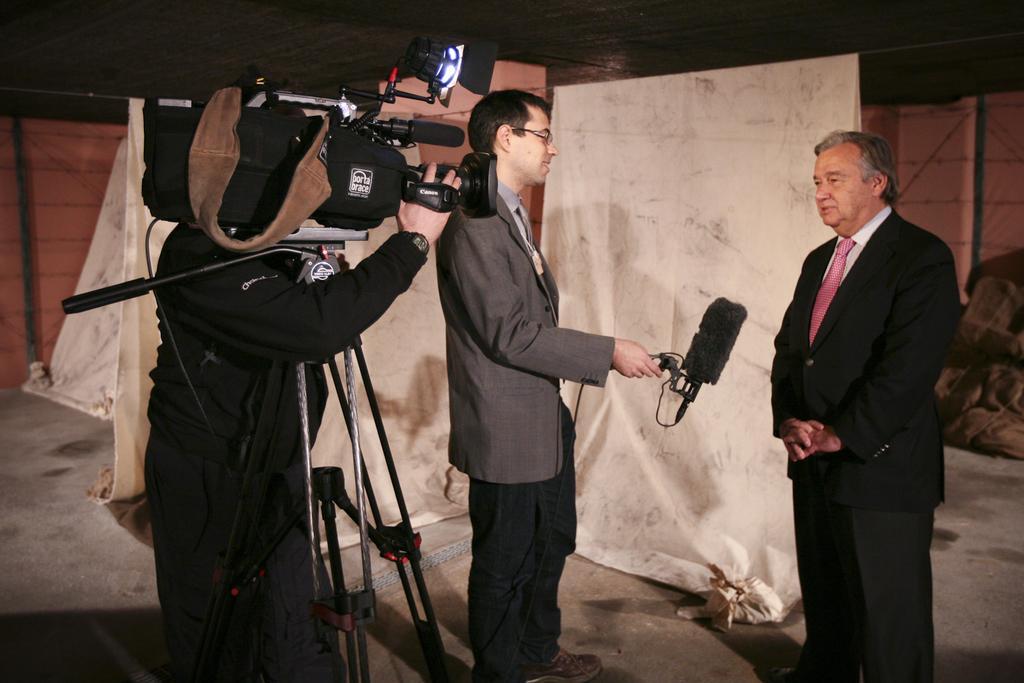Could you give a brief overview of what you see in this image? In this picture I can observe three men in this picture. One of them is holding video camera fixed to the tripod stand on the left side. In the background I can observe white color cloth. 